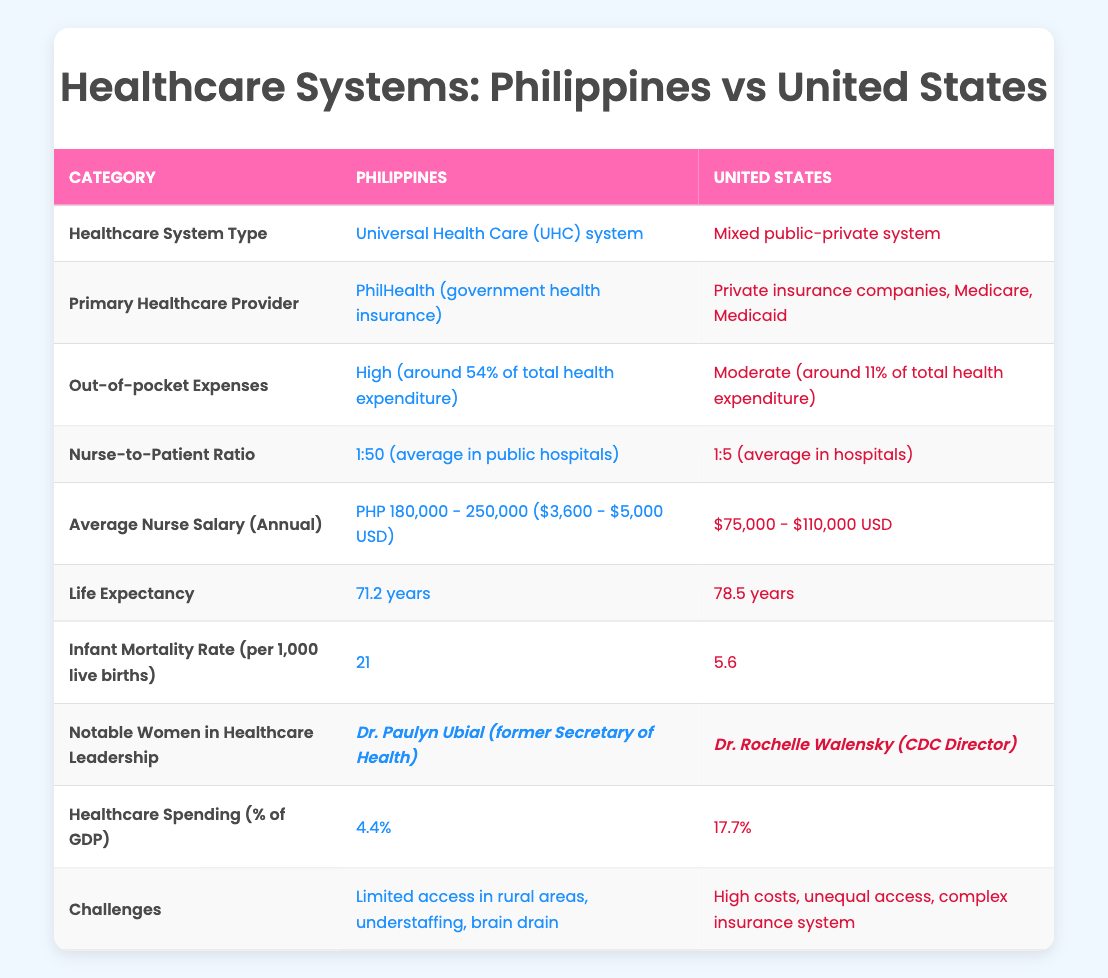What type of healthcare system does the Philippines have? According to the table, the Philippines has a Universal Health Care (UHC) system.
Answer: Universal Health Care (UHC) system Who is the primary healthcare provider in the United States? The table indicates that the primary healthcare provider in the United States is private insurance companies, Medicare, and Medicaid.
Answer: Private insurance companies, Medicare, Medicaid What is the out-of-pocket expense percentage for healthcare in the Philippines compared to the United States? The out-of-pocket expenses are around 54% of total health expenditure in the Philippines and around 11% in the United States.
Answer: 54% in the Philippines; 11% in the United States Is life expectancy higher in the United States than in the Philippines? According to the data, life expectancy in the United States is 78.5 years, while in the Philippines it is 71.2 years, indicating that life expectancy is higher in the United States.
Answer: Yes What is the difference in the average nurse salary between the Philippines and the United States? The average nurse salary in the Philippines ranges from PHP 180,000 - 250,000 (approximately $3,600 - $5,000 USD), whereas in the United States, it ranges from $75,000 - $110,000 USD. To find the difference, we consider the lower ends: $75,000 - $5,000 = $70,000, and also the upper ends: $110,000 - $3,600 = $106,400. Thus, the range of differences in nurse salaries is from $70,000 to $106,400, with the average nurse earning significantly more in the U.S.
Answer: $70,000 to $106,400 difference Which country has a greater nurse-to-patient ratio? The table clearly states that the nurse-to-patient ratio is 1:50 in the Philippines and 1:5 in the United States, which means the United States has a lower ratio, indicating more nurses per patient.
Answer: United States According to the table, is Dr. Paulyn Ubial a notable woman in healthcare leadership in the United States? The data lists Dr. Paulyn Ubial as a notable woman in healthcare leadership in the Philippines, while the notable woman in the United States is Dr. Rochelle Walensky. Therefore, the statement is false for Dr. Paulyn Ubial's association with the U.S.
Answer: No What challenges does the healthcare system in the Philippines face? According to the information in the table, the challenges faced by the healthcare system in the Philippines include limited access in rural areas, understaffing, and brain drain.
Answer: Limited access in rural areas, understaffing, brain drain What is the percentage of GDP that the United States spends on healthcare compared to the Philippines? The healthcare spending as a percentage of GDP is 17.7% for the United States and 4.4% for the Philippines, showing a significant difference in spending priorities between the two countries.
Answer: 17.7% in the United States; 4.4% in the Philippines How much more does the U.S. spend on healthcare as a percentage of GDP compared to the Philippines? To find the difference, we subtract the healthcare spending percentage of the Philippines from that of the United States: 17.7% - 4.4% = 13.3%. Therefore, the United States spends 13.3% more of its GDP on healthcare.
Answer: 13.3% more 